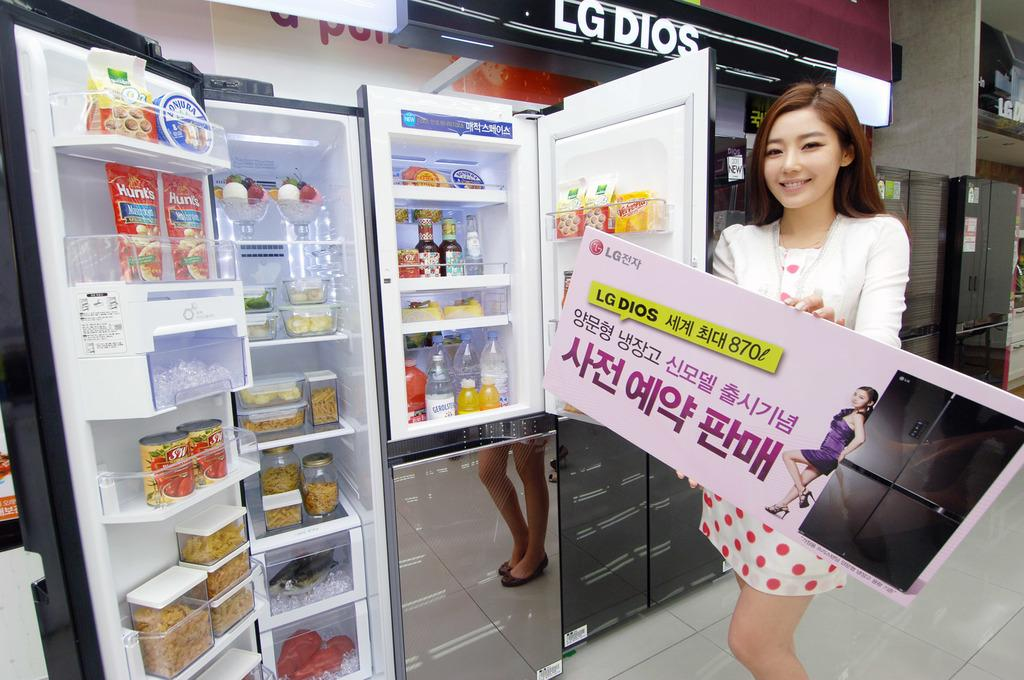<image>
Render a clear and concise summary of the photo. A girl holds a large box whilst standing underneath a sign reading LG Dios 